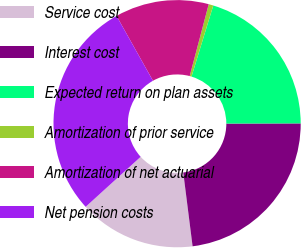<chart> <loc_0><loc_0><loc_500><loc_500><pie_chart><fcel>Service cost<fcel>Interest cost<fcel>Expected return on plan assets<fcel>Amortization of prior service<fcel>Amortization of net actuarial<fcel>Net pension costs<nl><fcel>15.26%<fcel>23.04%<fcel>20.24%<fcel>0.61%<fcel>12.27%<fcel>28.6%<nl></chart> 